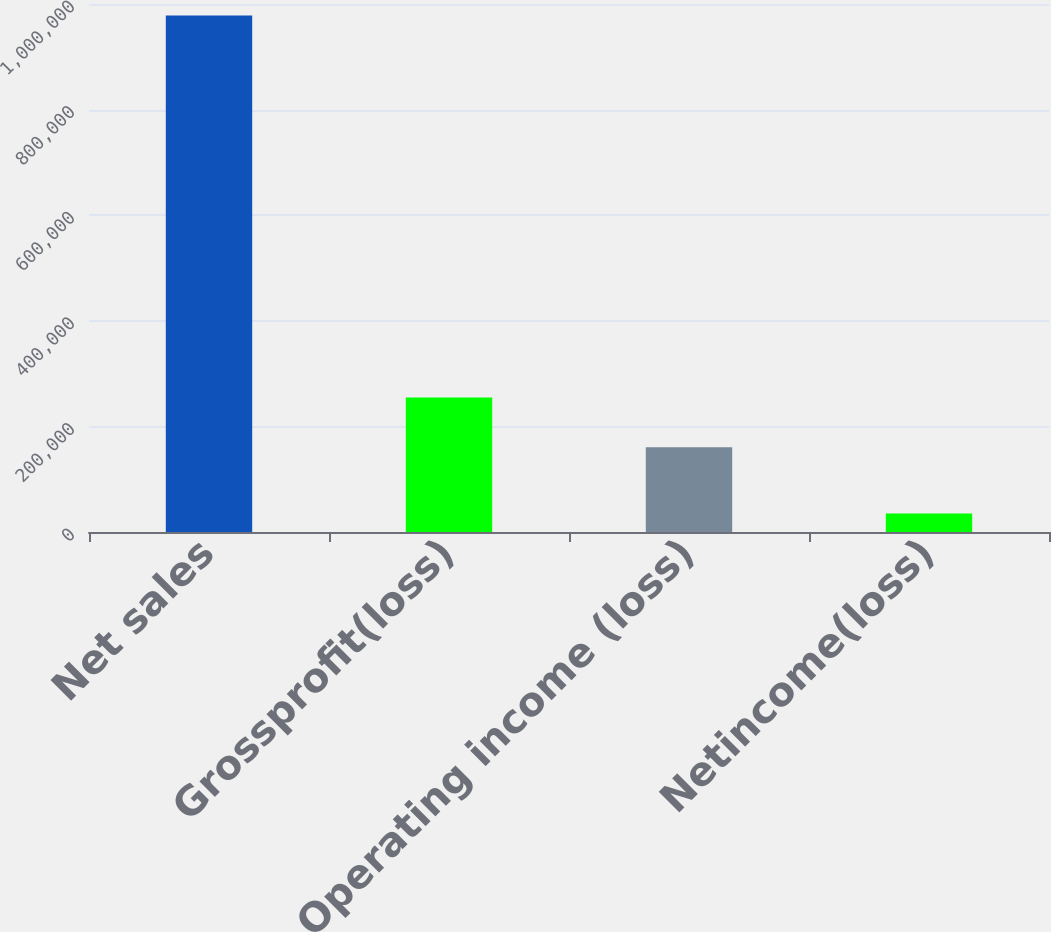<chart> <loc_0><loc_0><loc_500><loc_500><bar_chart><fcel>Net sales<fcel>Grossprofit(loss)<fcel>Operating income (loss)<fcel>Netincome(loss)<nl><fcel>978059<fcel>254612<fcel>160298<fcel>34924<nl></chart> 